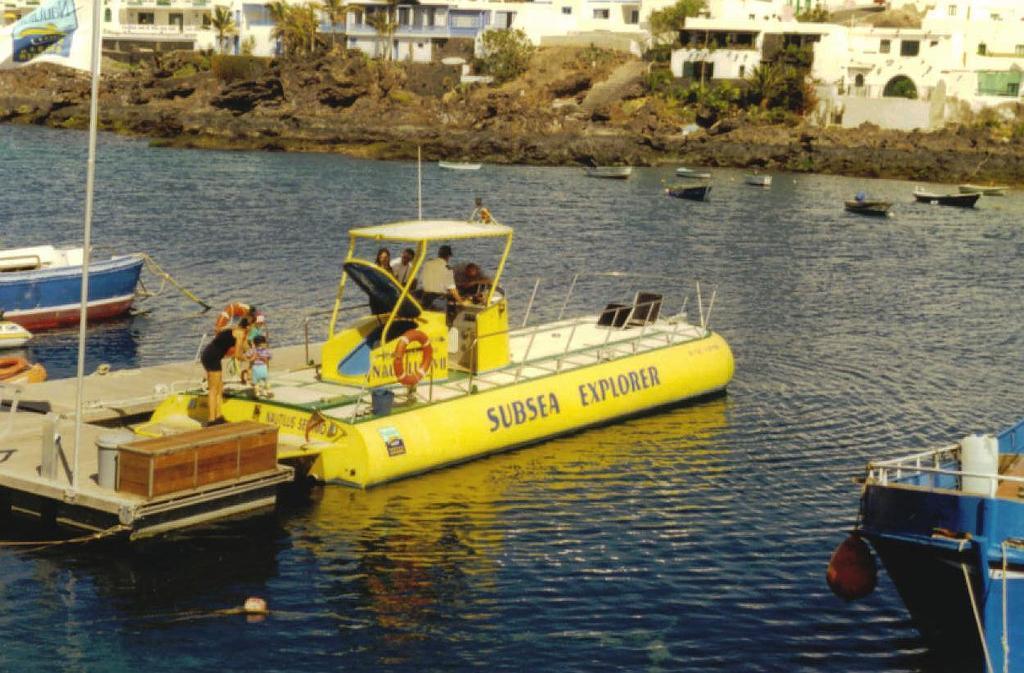In one or two sentences, can you explain what this image depicts? In this image we can see a few boats on the water, there are some trees, people, buildings, windows and a flag. 